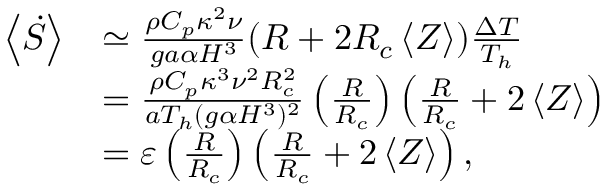<formula> <loc_0><loc_0><loc_500><loc_500>\begin{array} { r l } { \left < \dot { S } \right > } & { \simeq \frac { \rho C _ { p } \kappa ^ { 2 } \nu } { g a \alpha H ^ { 3 } } ( R + 2 R _ { c } \left < Z \right > ) \frac { \Delta T } { T _ { h } } } \\ & { = \frac { \rho C _ { p } \kappa ^ { 3 } \nu ^ { 2 } R _ { c } ^ { 2 } } { a T _ { h } ( g \alpha H ^ { 3 } ) ^ { 2 } } \left ( \frac { R } { R _ { c } } \right ) \left ( \frac { R } { R _ { c } } + 2 \left < Z \right > \right ) } \\ & { = \varepsilon \left ( \frac { R } { R _ { c } } \right ) \left ( \frac { R } { R _ { c } } + 2 \left < Z \right > \right ) , } \end{array}</formula> 